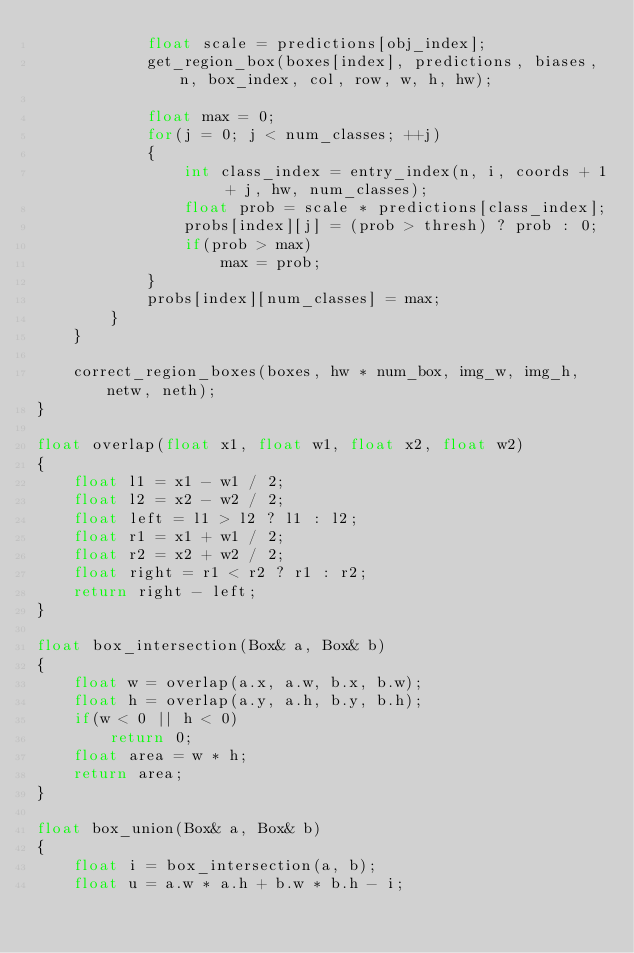Convert code to text. <code><loc_0><loc_0><loc_500><loc_500><_C++_>            float scale = predictions[obj_index];
            get_region_box(boxes[index], predictions, biases, n, box_index, col, row, w, h, hw);

            float max = 0;
            for(j = 0; j < num_classes; ++j)
            {
                int class_index = entry_index(n, i, coords + 1 + j, hw, num_classes);
                float prob = scale * predictions[class_index];
                probs[index][j] = (prob > thresh) ? prob : 0;
                if(prob > max)
                    max = prob;
            }
            probs[index][num_classes] = max;
        }
    }

    correct_region_boxes(boxes, hw * num_box, img_w, img_h, netw, neth);
}

float overlap(float x1, float w1, float x2, float w2)
{
    float l1 = x1 - w1 / 2;
    float l2 = x2 - w2 / 2;
    float left = l1 > l2 ? l1 : l2;
    float r1 = x1 + w1 / 2;
    float r2 = x2 + w2 / 2;
    float right = r1 < r2 ? r1 : r2;
    return right - left;
}

float box_intersection(Box& a, Box& b)
{
    float w = overlap(a.x, a.w, b.x, b.w);
    float h = overlap(a.y, a.h, b.y, b.h);
    if(w < 0 || h < 0)
        return 0;
    float area = w * h;
    return area;
}

float box_union(Box& a, Box& b)
{
    float i = box_intersection(a, b);
    float u = a.w * a.h + b.w * b.h - i;</code> 